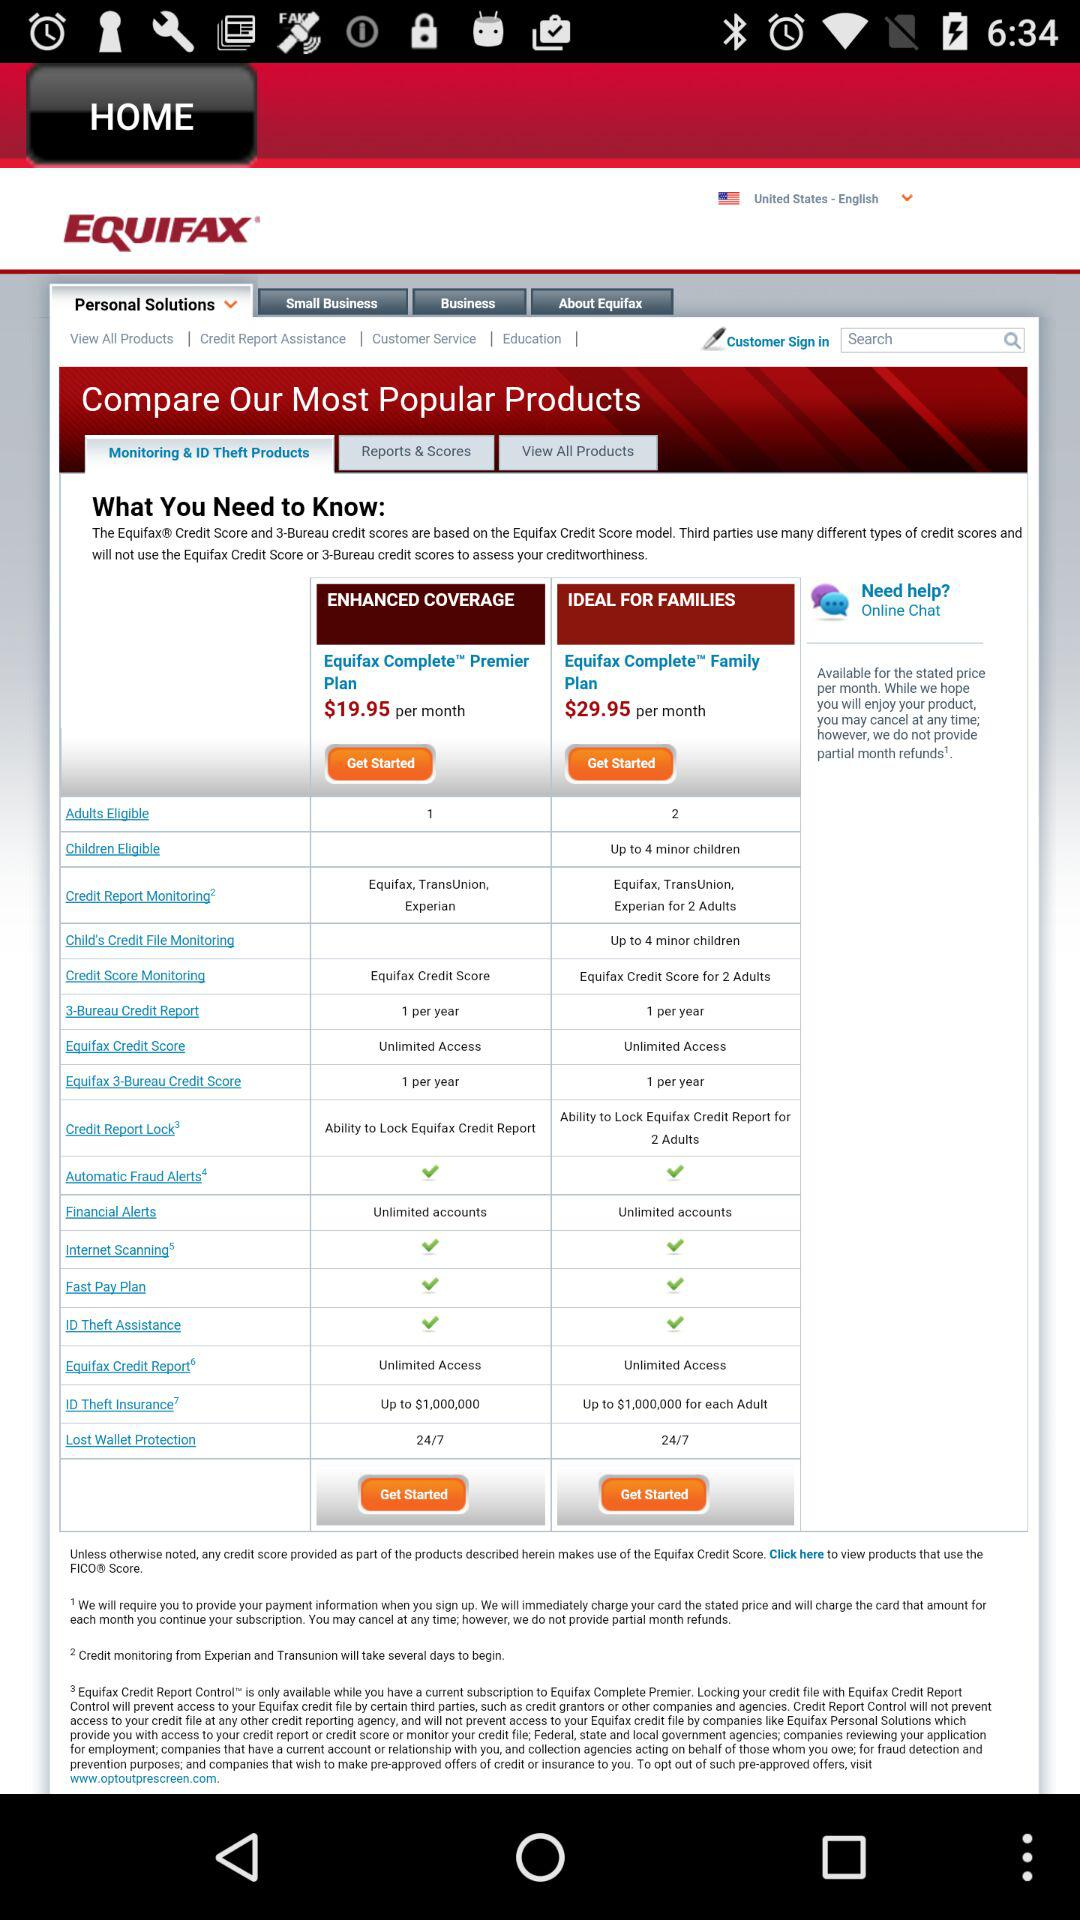Which state show is happening?
When the provided information is insufficient, respond with <no answer>. <no answer> 